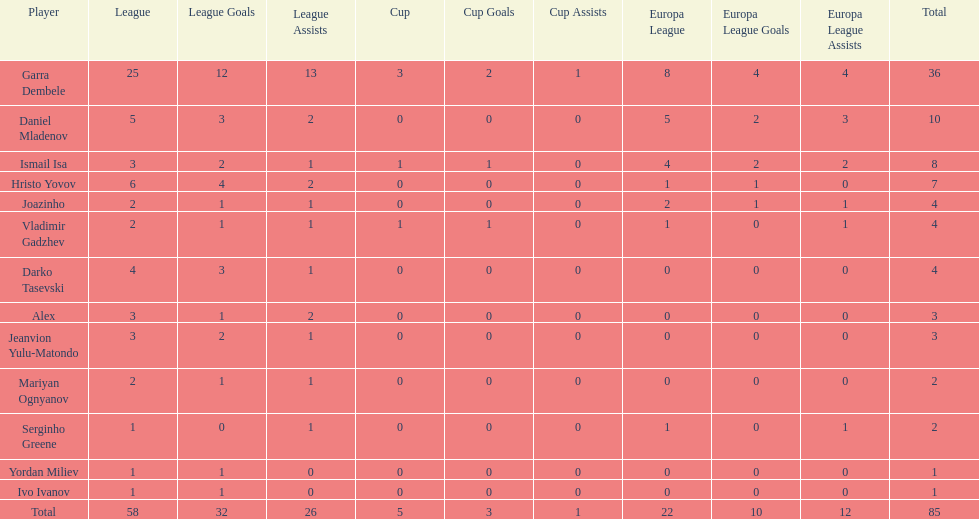Which player is in the same league as joazinho and vladimir gadzhev? Mariyan Ognyanov. 